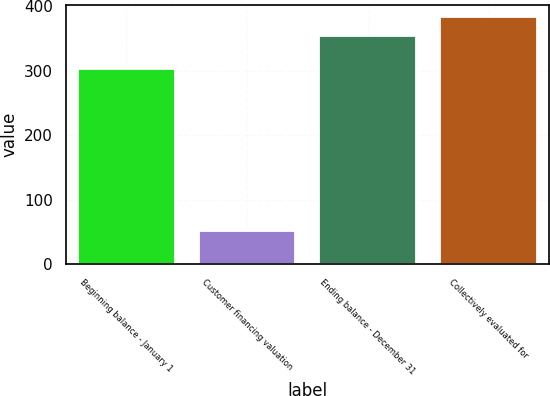Convert chart to OTSL. <chart><loc_0><loc_0><loc_500><loc_500><bar_chart><fcel>Beginning balance - January 1<fcel>Customer financing valuation<fcel>Ending balance - December 31<fcel>Collectively evaluated for<nl><fcel>302<fcel>51<fcel>353<fcel>383.2<nl></chart> 